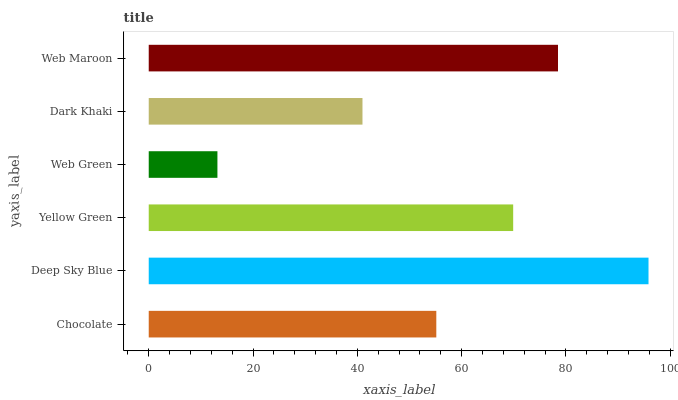Is Web Green the minimum?
Answer yes or no. Yes. Is Deep Sky Blue the maximum?
Answer yes or no. Yes. Is Yellow Green the minimum?
Answer yes or no. No. Is Yellow Green the maximum?
Answer yes or no. No. Is Deep Sky Blue greater than Yellow Green?
Answer yes or no. Yes. Is Yellow Green less than Deep Sky Blue?
Answer yes or no. Yes. Is Yellow Green greater than Deep Sky Blue?
Answer yes or no. No. Is Deep Sky Blue less than Yellow Green?
Answer yes or no. No. Is Yellow Green the high median?
Answer yes or no. Yes. Is Chocolate the low median?
Answer yes or no. Yes. Is Chocolate the high median?
Answer yes or no. No. Is Yellow Green the low median?
Answer yes or no. No. 